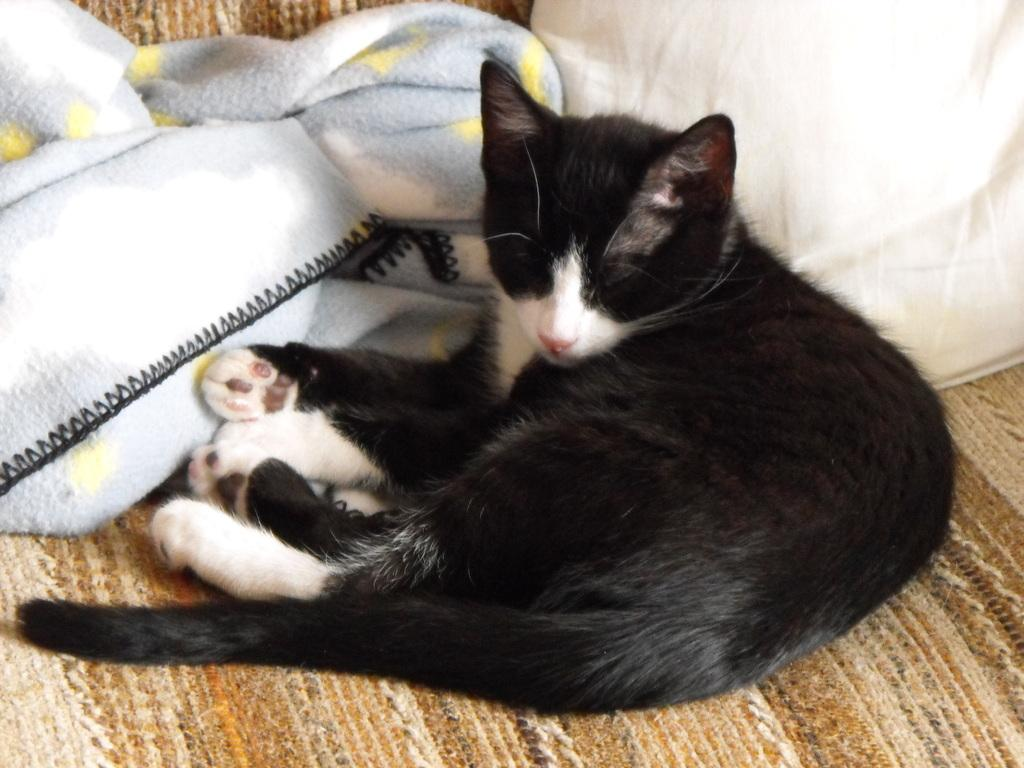What animal can be seen in the image? There is a cat in the image. Where is the cat located? The cat is on a mat. What else is present in the middle of the image? There are clothes in the middle of the image. How many legs does the tax have in the image? There is no tax present in the image, so it is not possible to determine the number of legs it might have. 